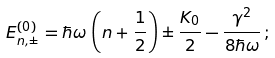Convert formula to latex. <formula><loc_0><loc_0><loc_500><loc_500>E _ { n , \pm } ^ { ( 0 ) } = \hbar { \omega } \, \left ( n + \frac { 1 } { 2 } \right ) \pm \frac { K _ { 0 } } { 2 } - \frac { \gamma ^ { 2 } } { 8 \hbar { \omega } } \, ;</formula> 